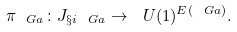Convert formula to latex. <formula><loc_0><loc_0><loc_500><loc_500>\pi _ { \ G a } \colon J _ { \S i _ { \ } G a } \to \ U ( 1 ) ^ { E ( \ G a ) } .</formula> 